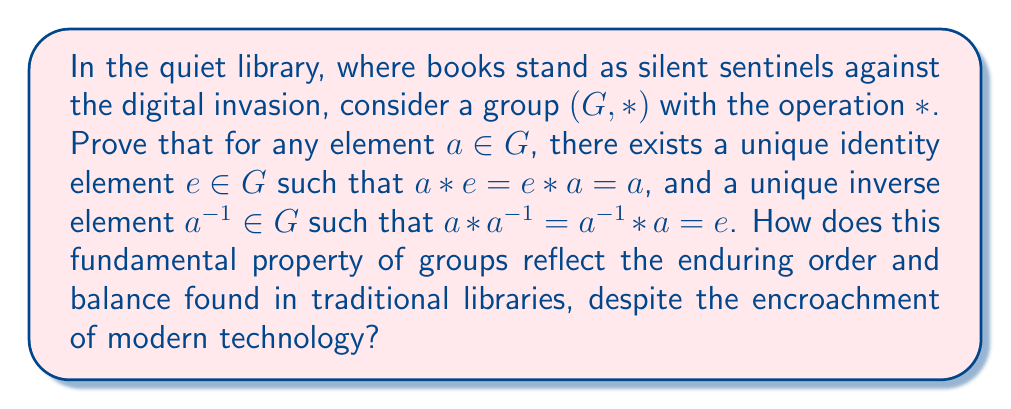Give your solution to this math problem. Let's approach this proof systematically, drawing parallels to the orderly nature of a traditional library:

1. Existence of Identity:
   a) Let $a \in G$ be any element. By the closure property of groups, there exists an element $b \in G$ such that $a * b = a$.
   b) Now, for any $x \in G$, we have:
      $x = x * (a * b) = (x * a) * b$ (by associativity)
   c) Let $e = a * b$. Then for any $x \in G$:
      $x * e = x * (a * b) = (x * a) * b = x$
   d) Therefore, $e$ is a right identity for all elements in $G$.
   e) Similarly, we can prove that $e$ is also a left identity.
   f) Uniqueness: If $e'$ is another identity, then $e = e * e' = e'$.

2. Existence of Inverse:
   a) Let $e$ be the identity element proven above.
   b) For any $a \in G$, by the closure property, there exists an element $c \in G$ such that $a * c = e$.
   c) Then: $c = e * c = (a * c) * c = a * (c * c)$ (by associativity)
   d) Let $a^{-1} = c$. Then:
      $a * a^{-1} = e$ and $a^{-1} * a = e$
   e) Uniqueness: If $a'$ is another inverse of $a$, then:
      $a' = a' * e = a' * (a * a^{-1}) = (a' * a) * a^{-1} = e * a^{-1} = a^{-1}$

This proof demonstrates that, like a well-organized library where each book has its unique place and can always be returned to that place, every element in a group has a unique identity and inverse. This inherent structure persists regardless of external changes, much like how the fundamental order of a library remains intact despite technological advancements.
Answer: The proof establishes the existence and uniqueness of both the identity element $e$ and the inverse element $a^{-1}$ for any $a \in G$ in the group $(G, *)$. This fundamental property ensures that for every element $a \in G$:

1. $\exists! e \in G : a * e = e * a = a$
2. $\exists! a^{-1} \in G : a * a^{-1} = a^{-1} * a = e$

These properties are intrinsic to the group structure, reflecting the enduring order found in traditional systems like libraries. 